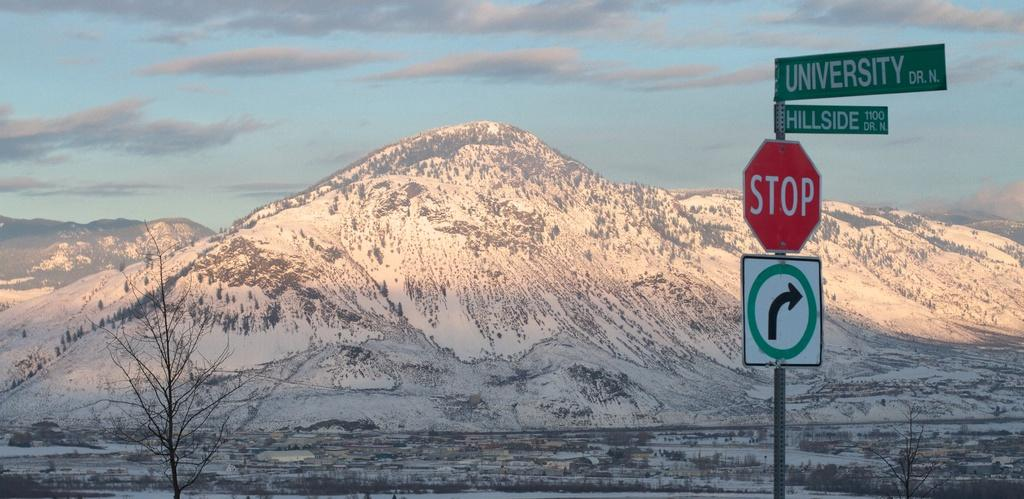<image>
Render a clear and concise summary of the photo. A snow covered mountain is in the background behind a stop sign and two street signs that say University and Hillside. 